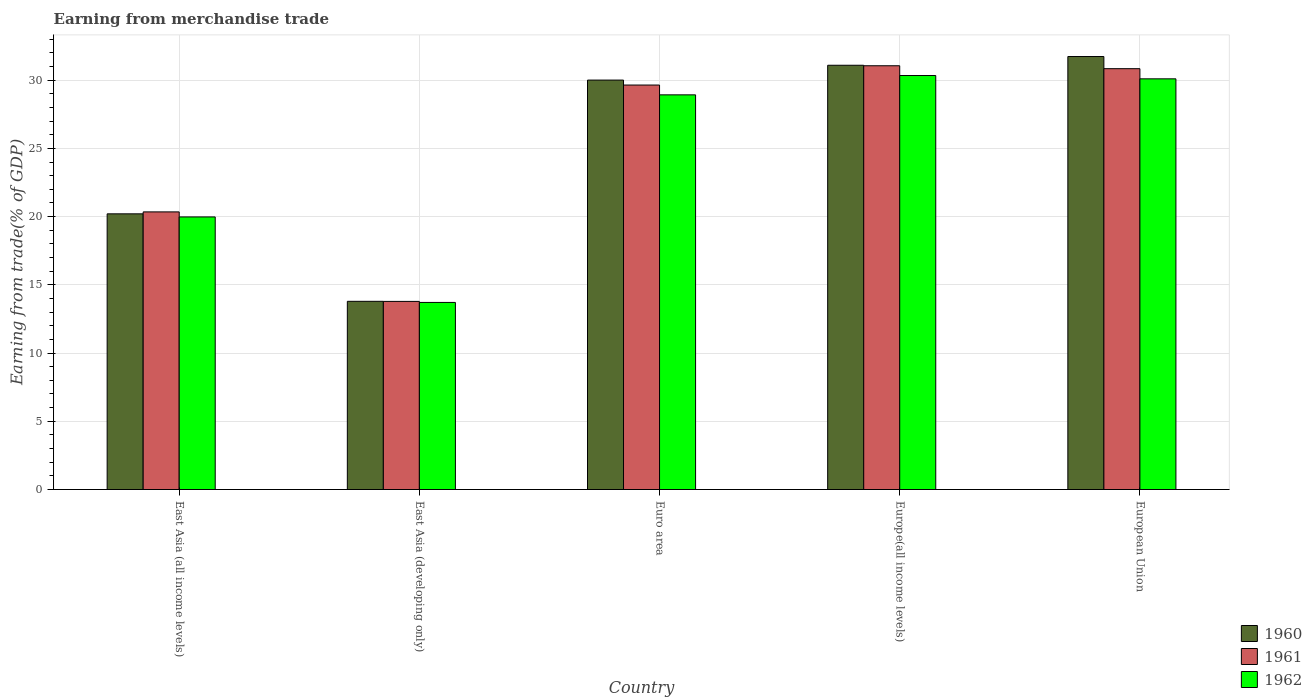How many groups of bars are there?
Your answer should be compact. 5. Are the number of bars per tick equal to the number of legend labels?
Make the answer very short. Yes. How many bars are there on the 2nd tick from the right?
Your answer should be compact. 3. What is the label of the 1st group of bars from the left?
Provide a short and direct response. East Asia (all income levels). What is the earnings from trade in 1961 in East Asia (all income levels)?
Offer a very short reply. 20.34. Across all countries, what is the maximum earnings from trade in 1961?
Make the answer very short. 31.05. Across all countries, what is the minimum earnings from trade in 1962?
Offer a very short reply. 13.71. In which country was the earnings from trade in 1962 minimum?
Provide a succinct answer. East Asia (developing only). What is the total earnings from trade in 1961 in the graph?
Your response must be concise. 125.66. What is the difference between the earnings from trade in 1962 in Euro area and that in European Union?
Your answer should be compact. -1.17. What is the difference between the earnings from trade in 1962 in East Asia (developing only) and the earnings from trade in 1961 in East Asia (all income levels)?
Keep it short and to the point. -6.63. What is the average earnings from trade in 1961 per country?
Keep it short and to the point. 25.13. What is the difference between the earnings from trade of/in 1960 and earnings from trade of/in 1961 in East Asia (all income levels)?
Keep it short and to the point. -0.14. In how many countries, is the earnings from trade in 1960 greater than 12 %?
Make the answer very short. 5. What is the ratio of the earnings from trade in 1960 in East Asia (developing only) to that in Europe(all income levels)?
Provide a succinct answer. 0.44. Is the earnings from trade in 1962 in East Asia (developing only) less than that in Europe(all income levels)?
Provide a succinct answer. Yes. Is the difference between the earnings from trade in 1960 in East Asia (developing only) and European Union greater than the difference between the earnings from trade in 1961 in East Asia (developing only) and European Union?
Your answer should be very brief. No. What is the difference between the highest and the second highest earnings from trade in 1960?
Make the answer very short. 1.09. What is the difference between the highest and the lowest earnings from trade in 1962?
Your answer should be very brief. 16.63. In how many countries, is the earnings from trade in 1961 greater than the average earnings from trade in 1961 taken over all countries?
Provide a short and direct response. 3. What does the 2nd bar from the left in Euro area represents?
Make the answer very short. 1961. What does the 1st bar from the right in East Asia (developing only) represents?
Keep it short and to the point. 1962. Is it the case that in every country, the sum of the earnings from trade in 1961 and earnings from trade in 1960 is greater than the earnings from trade in 1962?
Provide a short and direct response. Yes. How many countries are there in the graph?
Your response must be concise. 5. What is the difference between two consecutive major ticks on the Y-axis?
Keep it short and to the point. 5. Are the values on the major ticks of Y-axis written in scientific E-notation?
Your answer should be very brief. No. Does the graph contain any zero values?
Make the answer very short. No. Does the graph contain grids?
Keep it short and to the point. Yes. How many legend labels are there?
Offer a terse response. 3. How are the legend labels stacked?
Your response must be concise. Vertical. What is the title of the graph?
Provide a succinct answer. Earning from merchandise trade. Does "1998" appear as one of the legend labels in the graph?
Provide a succinct answer. No. What is the label or title of the Y-axis?
Keep it short and to the point. Earning from trade(% of GDP). What is the Earning from trade(% of GDP) in 1960 in East Asia (all income levels)?
Provide a succinct answer. 20.2. What is the Earning from trade(% of GDP) of 1961 in East Asia (all income levels)?
Offer a very short reply. 20.34. What is the Earning from trade(% of GDP) of 1962 in East Asia (all income levels)?
Give a very brief answer. 19.97. What is the Earning from trade(% of GDP) of 1960 in East Asia (developing only)?
Your answer should be very brief. 13.79. What is the Earning from trade(% of GDP) in 1961 in East Asia (developing only)?
Your answer should be very brief. 13.78. What is the Earning from trade(% of GDP) of 1962 in East Asia (developing only)?
Your answer should be compact. 13.71. What is the Earning from trade(% of GDP) of 1960 in Euro area?
Your answer should be compact. 30. What is the Earning from trade(% of GDP) of 1961 in Euro area?
Keep it short and to the point. 29.64. What is the Earning from trade(% of GDP) in 1962 in Euro area?
Your answer should be compact. 28.92. What is the Earning from trade(% of GDP) in 1960 in Europe(all income levels)?
Provide a succinct answer. 31.09. What is the Earning from trade(% of GDP) of 1961 in Europe(all income levels)?
Keep it short and to the point. 31.05. What is the Earning from trade(% of GDP) of 1962 in Europe(all income levels)?
Your response must be concise. 30.34. What is the Earning from trade(% of GDP) in 1960 in European Union?
Your answer should be compact. 31.73. What is the Earning from trade(% of GDP) in 1961 in European Union?
Your answer should be very brief. 30.84. What is the Earning from trade(% of GDP) of 1962 in European Union?
Ensure brevity in your answer.  30.09. Across all countries, what is the maximum Earning from trade(% of GDP) of 1960?
Make the answer very short. 31.73. Across all countries, what is the maximum Earning from trade(% of GDP) of 1961?
Keep it short and to the point. 31.05. Across all countries, what is the maximum Earning from trade(% of GDP) of 1962?
Offer a very short reply. 30.34. Across all countries, what is the minimum Earning from trade(% of GDP) of 1960?
Keep it short and to the point. 13.79. Across all countries, what is the minimum Earning from trade(% of GDP) in 1961?
Your answer should be very brief. 13.78. Across all countries, what is the minimum Earning from trade(% of GDP) in 1962?
Offer a terse response. 13.71. What is the total Earning from trade(% of GDP) in 1960 in the graph?
Make the answer very short. 126.81. What is the total Earning from trade(% of GDP) in 1961 in the graph?
Ensure brevity in your answer.  125.66. What is the total Earning from trade(% of GDP) of 1962 in the graph?
Your answer should be compact. 123.04. What is the difference between the Earning from trade(% of GDP) in 1960 in East Asia (all income levels) and that in East Asia (developing only)?
Your answer should be very brief. 6.41. What is the difference between the Earning from trade(% of GDP) of 1961 in East Asia (all income levels) and that in East Asia (developing only)?
Your answer should be very brief. 6.56. What is the difference between the Earning from trade(% of GDP) in 1962 in East Asia (all income levels) and that in East Asia (developing only)?
Keep it short and to the point. 6.27. What is the difference between the Earning from trade(% of GDP) of 1960 in East Asia (all income levels) and that in Euro area?
Ensure brevity in your answer.  -9.8. What is the difference between the Earning from trade(% of GDP) in 1961 in East Asia (all income levels) and that in Euro area?
Ensure brevity in your answer.  -9.3. What is the difference between the Earning from trade(% of GDP) in 1962 in East Asia (all income levels) and that in Euro area?
Ensure brevity in your answer.  -8.95. What is the difference between the Earning from trade(% of GDP) in 1960 in East Asia (all income levels) and that in Europe(all income levels)?
Offer a terse response. -10.89. What is the difference between the Earning from trade(% of GDP) in 1961 in East Asia (all income levels) and that in Europe(all income levels)?
Ensure brevity in your answer.  -10.71. What is the difference between the Earning from trade(% of GDP) in 1962 in East Asia (all income levels) and that in Europe(all income levels)?
Keep it short and to the point. -10.36. What is the difference between the Earning from trade(% of GDP) in 1960 in East Asia (all income levels) and that in European Union?
Offer a very short reply. -11.53. What is the difference between the Earning from trade(% of GDP) of 1961 in East Asia (all income levels) and that in European Union?
Offer a terse response. -10.49. What is the difference between the Earning from trade(% of GDP) in 1962 in East Asia (all income levels) and that in European Union?
Provide a succinct answer. -10.12. What is the difference between the Earning from trade(% of GDP) in 1960 in East Asia (developing only) and that in Euro area?
Offer a very short reply. -16.21. What is the difference between the Earning from trade(% of GDP) in 1961 in East Asia (developing only) and that in Euro area?
Offer a very short reply. -15.86. What is the difference between the Earning from trade(% of GDP) in 1962 in East Asia (developing only) and that in Euro area?
Ensure brevity in your answer.  -15.21. What is the difference between the Earning from trade(% of GDP) in 1960 in East Asia (developing only) and that in Europe(all income levels)?
Offer a terse response. -17.3. What is the difference between the Earning from trade(% of GDP) in 1961 in East Asia (developing only) and that in Europe(all income levels)?
Your answer should be very brief. -17.27. What is the difference between the Earning from trade(% of GDP) of 1962 in East Asia (developing only) and that in Europe(all income levels)?
Ensure brevity in your answer.  -16.63. What is the difference between the Earning from trade(% of GDP) of 1960 in East Asia (developing only) and that in European Union?
Provide a succinct answer. -17.94. What is the difference between the Earning from trade(% of GDP) of 1961 in East Asia (developing only) and that in European Union?
Your answer should be very brief. -17.05. What is the difference between the Earning from trade(% of GDP) in 1962 in East Asia (developing only) and that in European Union?
Provide a short and direct response. -16.38. What is the difference between the Earning from trade(% of GDP) of 1960 in Euro area and that in Europe(all income levels)?
Offer a terse response. -1.09. What is the difference between the Earning from trade(% of GDP) of 1961 in Euro area and that in Europe(all income levels)?
Your answer should be very brief. -1.41. What is the difference between the Earning from trade(% of GDP) in 1962 in Euro area and that in Europe(all income levels)?
Offer a very short reply. -1.42. What is the difference between the Earning from trade(% of GDP) of 1960 in Euro area and that in European Union?
Keep it short and to the point. -1.73. What is the difference between the Earning from trade(% of GDP) of 1961 in Euro area and that in European Union?
Your response must be concise. -1.2. What is the difference between the Earning from trade(% of GDP) in 1962 in Euro area and that in European Union?
Provide a succinct answer. -1.17. What is the difference between the Earning from trade(% of GDP) in 1960 in Europe(all income levels) and that in European Union?
Your response must be concise. -0.64. What is the difference between the Earning from trade(% of GDP) of 1961 in Europe(all income levels) and that in European Union?
Keep it short and to the point. 0.21. What is the difference between the Earning from trade(% of GDP) in 1962 in Europe(all income levels) and that in European Union?
Offer a terse response. 0.24. What is the difference between the Earning from trade(% of GDP) of 1960 in East Asia (all income levels) and the Earning from trade(% of GDP) of 1961 in East Asia (developing only)?
Your answer should be very brief. 6.42. What is the difference between the Earning from trade(% of GDP) of 1960 in East Asia (all income levels) and the Earning from trade(% of GDP) of 1962 in East Asia (developing only)?
Provide a short and direct response. 6.49. What is the difference between the Earning from trade(% of GDP) in 1961 in East Asia (all income levels) and the Earning from trade(% of GDP) in 1962 in East Asia (developing only)?
Make the answer very short. 6.63. What is the difference between the Earning from trade(% of GDP) in 1960 in East Asia (all income levels) and the Earning from trade(% of GDP) in 1961 in Euro area?
Provide a short and direct response. -9.44. What is the difference between the Earning from trade(% of GDP) of 1960 in East Asia (all income levels) and the Earning from trade(% of GDP) of 1962 in Euro area?
Keep it short and to the point. -8.72. What is the difference between the Earning from trade(% of GDP) of 1961 in East Asia (all income levels) and the Earning from trade(% of GDP) of 1962 in Euro area?
Provide a succinct answer. -8.58. What is the difference between the Earning from trade(% of GDP) in 1960 in East Asia (all income levels) and the Earning from trade(% of GDP) in 1961 in Europe(all income levels)?
Your answer should be very brief. -10.85. What is the difference between the Earning from trade(% of GDP) in 1960 in East Asia (all income levels) and the Earning from trade(% of GDP) in 1962 in Europe(all income levels)?
Ensure brevity in your answer.  -10.14. What is the difference between the Earning from trade(% of GDP) of 1961 in East Asia (all income levels) and the Earning from trade(% of GDP) of 1962 in Europe(all income levels)?
Ensure brevity in your answer.  -9.99. What is the difference between the Earning from trade(% of GDP) of 1960 in East Asia (all income levels) and the Earning from trade(% of GDP) of 1961 in European Union?
Your answer should be compact. -10.64. What is the difference between the Earning from trade(% of GDP) of 1960 in East Asia (all income levels) and the Earning from trade(% of GDP) of 1962 in European Union?
Keep it short and to the point. -9.89. What is the difference between the Earning from trade(% of GDP) in 1961 in East Asia (all income levels) and the Earning from trade(% of GDP) in 1962 in European Union?
Your answer should be very brief. -9.75. What is the difference between the Earning from trade(% of GDP) of 1960 in East Asia (developing only) and the Earning from trade(% of GDP) of 1961 in Euro area?
Your answer should be very brief. -15.85. What is the difference between the Earning from trade(% of GDP) of 1960 in East Asia (developing only) and the Earning from trade(% of GDP) of 1962 in Euro area?
Offer a very short reply. -15.13. What is the difference between the Earning from trade(% of GDP) of 1961 in East Asia (developing only) and the Earning from trade(% of GDP) of 1962 in Euro area?
Offer a terse response. -15.14. What is the difference between the Earning from trade(% of GDP) in 1960 in East Asia (developing only) and the Earning from trade(% of GDP) in 1961 in Europe(all income levels)?
Keep it short and to the point. -17.26. What is the difference between the Earning from trade(% of GDP) in 1960 in East Asia (developing only) and the Earning from trade(% of GDP) in 1962 in Europe(all income levels)?
Your answer should be compact. -16.55. What is the difference between the Earning from trade(% of GDP) of 1961 in East Asia (developing only) and the Earning from trade(% of GDP) of 1962 in Europe(all income levels)?
Provide a succinct answer. -16.55. What is the difference between the Earning from trade(% of GDP) in 1960 in East Asia (developing only) and the Earning from trade(% of GDP) in 1961 in European Union?
Ensure brevity in your answer.  -17.05. What is the difference between the Earning from trade(% of GDP) in 1960 in East Asia (developing only) and the Earning from trade(% of GDP) in 1962 in European Union?
Keep it short and to the point. -16.3. What is the difference between the Earning from trade(% of GDP) of 1961 in East Asia (developing only) and the Earning from trade(% of GDP) of 1962 in European Union?
Your answer should be compact. -16.31. What is the difference between the Earning from trade(% of GDP) in 1960 in Euro area and the Earning from trade(% of GDP) in 1961 in Europe(all income levels)?
Provide a succinct answer. -1.05. What is the difference between the Earning from trade(% of GDP) of 1960 in Euro area and the Earning from trade(% of GDP) of 1962 in Europe(all income levels)?
Make the answer very short. -0.33. What is the difference between the Earning from trade(% of GDP) in 1961 in Euro area and the Earning from trade(% of GDP) in 1962 in Europe(all income levels)?
Ensure brevity in your answer.  -0.7. What is the difference between the Earning from trade(% of GDP) in 1960 in Euro area and the Earning from trade(% of GDP) in 1961 in European Union?
Ensure brevity in your answer.  -0.84. What is the difference between the Earning from trade(% of GDP) in 1960 in Euro area and the Earning from trade(% of GDP) in 1962 in European Union?
Ensure brevity in your answer.  -0.09. What is the difference between the Earning from trade(% of GDP) of 1961 in Euro area and the Earning from trade(% of GDP) of 1962 in European Union?
Your answer should be compact. -0.45. What is the difference between the Earning from trade(% of GDP) in 1960 in Europe(all income levels) and the Earning from trade(% of GDP) in 1961 in European Union?
Offer a very short reply. 0.25. What is the difference between the Earning from trade(% of GDP) of 1960 in Europe(all income levels) and the Earning from trade(% of GDP) of 1962 in European Union?
Make the answer very short. 0.99. What is the difference between the Earning from trade(% of GDP) in 1961 in Europe(all income levels) and the Earning from trade(% of GDP) in 1962 in European Union?
Your answer should be very brief. 0.96. What is the average Earning from trade(% of GDP) in 1960 per country?
Ensure brevity in your answer.  25.36. What is the average Earning from trade(% of GDP) of 1961 per country?
Ensure brevity in your answer.  25.13. What is the average Earning from trade(% of GDP) in 1962 per country?
Your answer should be very brief. 24.61. What is the difference between the Earning from trade(% of GDP) in 1960 and Earning from trade(% of GDP) in 1961 in East Asia (all income levels)?
Offer a very short reply. -0.14. What is the difference between the Earning from trade(% of GDP) of 1960 and Earning from trade(% of GDP) of 1962 in East Asia (all income levels)?
Your answer should be compact. 0.23. What is the difference between the Earning from trade(% of GDP) in 1961 and Earning from trade(% of GDP) in 1962 in East Asia (all income levels)?
Your answer should be compact. 0.37. What is the difference between the Earning from trade(% of GDP) in 1960 and Earning from trade(% of GDP) in 1961 in East Asia (developing only)?
Keep it short and to the point. 0.01. What is the difference between the Earning from trade(% of GDP) of 1960 and Earning from trade(% of GDP) of 1962 in East Asia (developing only)?
Offer a very short reply. 0.08. What is the difference between the Earning from trade(% of GDP) of 1961 and Earning from trade(% of GDP) of 1962 in East Asia (developing only)?
Offer a very short reply. 0.08. What is the difference between the Earning from trade(% of GDP) of 1960 and Earning from trade(% of GDP) of 1961 in Euro area?
Keep it short and to the point. 0.36. What is the difference between the Earning from trade(% of GDP) in 1960 and Earning from trade(% of GDP) in 1962 in Euro area?
Your response must be concise. 1.08. What is the difference between the Earning from trade(% of GDP) in 1961 and Earning from trade(% of GDP) in 1962 in Euro area?
Your answer should be compact. 0.72. What is the difference between the Earning from trade(% of GDP) in 1960 and Earning from trade(% of GDP) in 1961 in Europe(all income levels)?
Provide a succinct answer. 0.04. What is the difference between the Earning from trade(% of GDP) in 1960 and Earning from trade(% of GDP) in 1962 in Europe(all income levels)?
Keep it short and to the point. 0.75. What is the difference between the Earning from trade(% of GDP) of 1961 and Earning from trade(% of GDP) of 1962 in Europe(all income levels)?
Your answer should be very brief. 0.72. What is the difference between the Earning from trade(% of GDP) in 1960 and Earning from trade(% of GDP) in 1961 in European Union?
Your response must be concise. 0.89. What is the difference between the Earning from trade(% of GDP) of 1960 and Earning from trade(% of GDP) of 1962 in European Union?
Your response must be concise. 1.64. What is the difference between the Earning from trade(% of GDP) of 1961 and Earning from trade(% of GDP) of 1962 in European Union?
Offer a very short reply. 0.74. What is the ratio of the Earning from trade(% of GDP) of 1960 in East Asia (all income levels) to that in East Asia (developing only)?
Give a very brief answer. 1.46. What is the ratio of the Earning from trade(% of GDP) in 1961 in East Asia (all income levels) to that in East Asia (developing only)?
Your answer should be very brief. 1.48. What is the ratio of the Earning from trade(% of GDP) of 1962 in East Asia (all income levels) to that in East Asia (developing only)?
Offer a very short reply. 1.46. What is the ratio of the Earning from trade(% of GDP) in 1960 in East Asia (all income levels) to that in Euro area?
Your answer should be compact. 0.67. What is the ratio of the Earning from trade(% of GDP) of 1961 in East Asia (all income levels) to that in Euro area?
Your answer should be compact. 0.69. What is the ratio of the Earning from trade(% of GDP) in 1962 in East Asia (all income levels) to that in Euro area?
Your answer should be compact. 0.69. What is the ratio of the Earning from trade(% of GDP) in 1960 in East Asia (all income levels) to that in Europe(all income levels)?
Your response must be concise. 0.65. What is the ratio of the Earning from trade(% of GDP) of 1961 in East Asia (all income levels) to that in Europe(all income levels)?
Offer a very short reply. 0.66. What is the ratio of the Earning from trade(% of GDP) in 1962 in East Asia (all income levels) to that in Europe(all income levels)?
Offer a terse response. 0.66. What is the ratio of the Earning from trade(% of GDP) in 1960 in East Asia (all income levels) to that in European Union?
Offer a very short reply. 0.64. What is the ratio of the Earning from trade(% of GDP) of 1961 in East Asia (all income levels) to that in European Union?
Your response must be concise. 0.66. What is the ratio of the Earning from trade(% of GDP) of 1962 in East Asia (all income levels) to that in European Union?
Offer a terse response. 0.66. What is the ratio of the Earning from trade(% of GDP) of 1960 in East Asia (developing only) to that in Euro area?
Your response must be concise. 0.46. What is the ratio of the Earning from trade(% of GDP) of 1961 in East Asia (developing only) to that in Euro area?
Provide a short and direct response. 0.47. What is the ratio of the Earning from trade(% of GDP) in 1962 in East Asia (developing only) to that in Euro area?
Ensure brevity in your answer.  0.47. What is the ratio of the Earning from trade(% of GDP) of 1960 in East Asia (developing only) to that in Europe(all income levels)?
Offer a very short reply. 0.44. What is the ratio of the Earning from trade(% of GDP) of 1961 in East Asia (developing only) to that in Europe(all income levels)?
Your answer should be very brief. 0.44. What is the ratio of the Earning from trade(% of GDP) in 1962 in East Asia (developing only) to that in Europe(all income levels)?
Your answer should be compact. 0.45. What is the ratio of the Earning from trade(% of GDP) of 1960 in East Asia (developing only) to that in European Union?
Ensure brevity in your answer.  0.43. What is the ratio of the Earning from trade(% of GDP) in 1961 in East Asia (developing only) to that in European Union?
Your answer should be compact. 0.45. What is the ratio of the Earning from trade(% of GDP) in 1962 in East Asia (developing only) to that in European Union?
Make the answer very short. 0.46. What is the ratio of the Earning from trade(% of GDP) of 1960 in Euro area to that in Europe(all income levels)?
Offer a terse response. 0.97. What is the ratio of the Earning from trade(% of GDP) of 1961 in Euro area to that in Europe(all income levels)?
Provide a succinct answer. 0.95. What is the ratio of the Earning from trade(% of GDP) of 1962 in Euro area to that in Europe(all income levels)?
Offer a terse response. 0.95. What is the ratio of the Earning from trade(% of GDP) in 1960 in Euro area to that in European Union?
Your response must be concise. 0.95. What is the ratio of the Earning from trade(% of GDP) of 1961 in Euro area to that in European Union?
Make the answer very short. 0.96. What is the ratio of the Earning from trade(% of GDP) in 1962 in Euro area to that in European Union?
Provide a short and direct response. 0.96. What is the ratio of the Earning from trade(% of GDP) of 1960 in Europe(all income levels) to that in European Union?
Make the answer very short. 0.98. What is the ratio of the Earning from trade(% of GDP) in 1962 in Europe(all income levels) to that in European Union?
Offer a terse response. 1.01. What is the difference between the highest and the second highest Earning from trade(% of GDP) of 1960?
Keep it short and to the point. 0.64. What is the difference between the highest and the second highest Earning from trade(% of GDP) of 1961?
Ensure brevity in your answer.  0.21. What is the difference between the highest and the second highest Earning from trade(% of GDP) in 1962?
Provide a short and direct response. 0.24. What is the difference between the highest and the lowest Earning from trade(% of GDP) in 1960?
Make the answer very short. 17.94. What is the difference between the highest and the lowest Earning from trade(% of GDP) in 1961?
Give a very brief answer. 17.27. What is the difference between the highest and the lowest Earning from trade(% of GDP) of 1962?
Give a very brief answer. 16.63. 